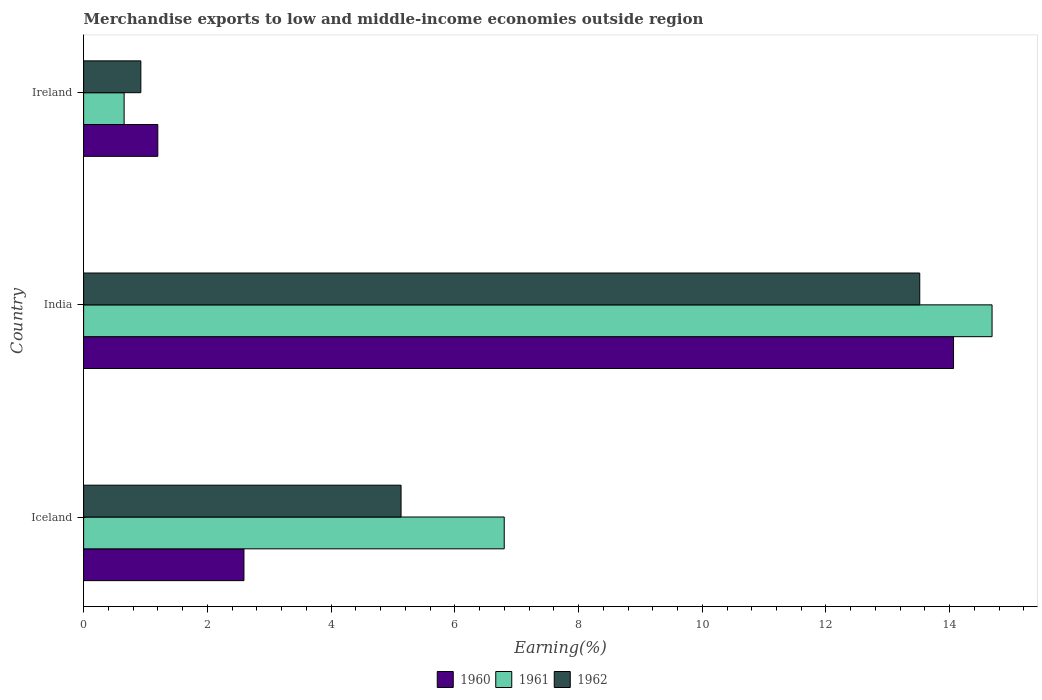How many different coloured bars are there?
Your answer should be very brief. 3. Are the number of bars per tick equal to the number of legend labels?
Your answer should be compact. Yes. Are the number of bars on each tick of the Y-axis equal?
Keep it short and to the point. Yes. How many bars are there on the 1st tick from the top?
Keep it short and to the point. 3. What is the label of the 1st group of bars from the top?
Your answer should be compact. Ireland. In how many cases, is the number of bars for a given country not equal to the number of legend labels?
Give a very brief answer. 0. What is the percentage of amount earned from merchandise exports in 1962 in Iceland?
Your answer should be compact. 5.13. Across all countries, what is the maximum percentage of amount earned from merchandise exports in 1960?
Provide a short and direct response. 14.06. Across all countries, what is the minimum percentage of amount earned from merchandise exports in 1961?
Offer a very short reply. 0.65. In which country was the percentage of amount earned from merchandise exports in 1960 minimum?
Your response must be concise. Ireland. What is the total percentage of amount earned from merchandise exports in 1962 in the graph?
Your answer should be very brief. 19.57. What is the difference between the percentage of amount earned from merchandise exports in 1960 in Iceland and that in India?
Your answer should be very brief. -11.47. What is the difference between the percentage of amount earned from merchandise exports in 1960 in India and the percentage of amount earned from merchandise exports in 1961 in Iceland?
Offer a very short reply. 7.26. What is the average percentage of amount earned from merchandise exports in 1961 per country?
Offer a very short reply. 7.38. What is the difference between the percentage of amount earned from merchandise exports in 1962 and percentage of amount earned from merchandise exports in 1961 in India?
Your answer should be compact. -1.17. In how many countries, is the percentage of amount earned from merchandise exports in 1960 greater than 11.2 %?
Make the answer very short. 1. What is the ratio of the percentage of amount earned from merchandise exports in 1960 in India to that in Ireland?
Make the answer very short. 11.73. Is the percentage of amount earned from merchandise exports in 1960 in Iceland less than that in Ireland?
Offer a terse response. No. Is the difference between the percentage of amount earned from merchandise exports in 1962 in Iceland and Ireland greater than the difference between the percentage of amount earned from merchandise exports in 1961 in Iceland and Ireland?
Your response must be concise. No. What is the difference between the highest and the second highest percentage of amount earned from merchandise exports in 1960?
Ensure brevity in your answer.  11.47. What is the difference between the highest and the lowest percentage of amount earned from merchandise exports in 1960?
Ensure brevity in your answer.  12.86. In how many countries, is the percentage of amount earned from merchandise exports in 1962 greater than the average percentage of amount earned from merchandise exports in 1962 taken over all countries?
Your answer should be very brief. 1. What does the 2nd bar from the top in Iceland represents?
Provide a succinct answer. 1961. Is it the case that in every country, the sum of the percentage of amount earned from merchandise exports in 1960 and percentage of amount earned from merchandise exports in 1961 is greater than the percentage of amount earned from merchandise exports in 1962?
Ensure brevity in your answer.  Yes. What is the difference between two consecutive major ticks on the X-axis?
Keep it short and to the point. 2. Are the values on the major ticks of X-axis written in scientific E-notation?
Give a very brief answer. No. Does the graph contain grids?
Ensure brevity in your answer.  No. How many legend labels are there?
Ensure brevity in your answer.  3. What is the title of the graph?
Your response must be concise. Merchandise exports to low and middle-income economies outside region. Does "2008" appear as one of the legend labels in the graph?
Make the answer very short. No. What is the label or title of the X-axis?
Provide a succinct answer. Earning(%). What is the Earning(%) of 1960 in Iceland?
Make the answer very short. 2.59. What is the Earning(%) of 1961 in Iceland?
Offer a terse response. 6.8. What is the Earning(%) in 1962 in Iceland?
Your answer should be compact. 5.13. What is the Earning(%) in 1960 in India?
Ensure brevity in your answer.  14.06. What is the Earning(%) of 1961 in India?
Offer a terse response. 14.68. What is the Earning(%) in 1962 in India?
Your response must be concise. 13.52. What is the Earning(%) in 1960 in Ireland?
Provide a succinct answer. 1.2. What is the Earning(%) in 1961 in Ireland?
Make the answer very short. 0.65. What is the Earning(%) of 1962 in Ireland?
Your answer should be compact. 0.92. Across all countries, what is the maximum Earning(%) of 1960?
Your response must be concise. 14.06. Across all countries, what is the maximum Earning(%) in 1961?
Give a very brief answer. 14.68. Across all countries, what is the maximum Earning(%) of 1962?
Make the answer very short. 13.52. Across all countries, what is the minimum Earning(%) of 1960?
Your answer should be compact. 1.2. Across all countries, what is the minimum Earning(%) in 1961?
Ensure brevity in your answer.  0.65. Across all countries, what is the minimum Earning(%) of 1962?
Keep it short and to the point. 0.92. What is the total Earning(%) of 1960 in the graph?
Provide a succinct answer. 17.85. What is the total Earning(%) in 1961 in the graph?
Give a very brief answer. 22.14. What is the total Earning(%) in 1962 in the graph?
Your answer should be compact. 19.57. What is the difference between the Earning(%) of 1960 in Iceland and that in India?
Offer a very short reply. -11.47. What is the difference between the Earning(%) of 1961 in Iceland and that in India?
Give a very brief answer. -7.89. What is the difference between the Earning(%) in 1962 in Iceland and that in India?
Offer a very short reply. -8.38. What is the difference between the Earning(%) in 1960 in Iceland and that in Ireland?
Your answer should be compact. 1.39. What is the difference between the Earning(%) in 1961 in Iceland and that in Ireland?
Keep it short and to the point. 6.14. What is the difference between the Earning(%) in 1962 in Iceland and that in Ireland?
Offer a terse response. 4.21. What is the difference between the Earning(%) in 1960 in India and that in Ireland?
Keep it short and to the point. 12.86. What is the difference between the Earning(%) of 1961 in India and that in Ireland?
Provide a short and direct response. 14.03. What is the difference between the Earning(%) of 1962 in India and that in Ireland?
Provide a succinct answer. 12.59. What is the difference between the Earning(%) in 1960 in Iceland and the Earning(%) in 1961 in India?
Your answer should be very brief. -12.09. What is the difference between the Earning(%) in 1960 in Iceland and the Earning(%) in 1962 in India?
Your response must be concise. -10.92. What is the difference between the Earning(%) of 1961 in Iceland and the Earning(%) of 1962 in India?
Provide a short and direct response. -6.72. What is the difference between the Earning(%) of 1960 in Iceland and the Earning(%) of 1961 in Ireland?
Ensure brevity in your answer.  1.94. What is the difference between the Earning(%) in 1960 in Iceland and the Earning(%) in 1962 in Ireland?
Your response must be concise. 1.67. What is the difference between the Earning(%) in 1961 in Iceland and the Earning(%) in 1962 in Ireland?
Provide a succinct answer. 5.87. What is the difference between the Earning(%) in 1960 in India and the Earning(%) in 1961 in Ireland?
Offer a terse response. 13.41. What is the difference between the Earning(%) of 1960 in India and the Earning(%) of 1962 in Ireland?
Make the answer very short. 13.14. What is the difference between the Earning(%) in 1961 in India and the Earning(%) in 1962 in Ireland?
Keep it short and to the point. 13.76. What is the average Earning(%) in 1960 per country?
Provide a succinct answer. 5.95. What is the average Earning(%) in 1961 per country?
Provide a succinct answer. 7.38. What is the average Earning(%) of 1962 per country?
Provide a succinct answer. 6.52. What is the difference between the Earning(%) of 1960 and Earning(%) of 1961 in Iceland?
Offer a very short reply. -4.21. What is the difference between the Earning(%) of 1960 and Earning(%) of 1962 in Iceland?
Keep it short and to the point. -2.54. What is the difference between the Earning(%) in 1961 and Earning(%) in 1962 in Iceland?
Keep it short and to the point. 1.67. What is the difference between the Earning(%) of 1960 and Earning(%) of 1961 in India?
Your answer should be very brief. -0.62. What is the difference between the Earning(%) of 1960 and Earning(%) of 1962 in India?
Keep it short and to the point. 0.55. What is the difference between the Earning(%) in 1961 and Earning(%) in 1962 in India?
Give a very brief answer. 1.17. What is the difference between the Earning(%) in 1960 and Earning(%) in 1961 in Ireland?
Offer a terse response. 0.54. What is the difference between the Earning(%) in 1960 and Earning(%) in 1962 in Ireland?
Keep it short and to the point. 0.27. What is the difference between the Earning(%) of 1961 and Earning(%) of 1962 in Ireland?
Provide a succinct answer. -0.27. What is the ratio of the Earning(%) in 1960 in Iceland to that in India?
Provide a succinct answer. 0.18. What is the ratio of the Earning(%) of 1961 in Iceland to that in India?
Your answer should be very brief. 0.46. What is the ratio of the Earning(%) in 1962 in Iceland to that in India?
Your response must be concise. 0.38. What is the ratio of the Earning(%) of 1960 in Iceland to that in Ireland?
Offer a very short reply. 2.16. What is the ratio of the Earning(%) of 1961 in Iceland to that in Ireland?
Give a very brief answer. 10.39. What is the ratio of the Earning(%) of 1962 in Iceland to that in Ireland?
Offer a very short reply. 5.55. What is the ratio of the Earning(%) of 1960 in India to that in Ireland?
Provide a succinct answer. 11.73. What is the ratio of the Earning(%) in 1961 in India to that in Ireland?
Offer a terse response. 22.44. What is the ratio of the Earning(%) of 1962 in India to that in Ireland?
Make the answer very short. 14.61. What is the difference between the highest and the second highest Earning(%) in 1960?
Provide a short and direct response. 11.47. What is the difference between the highest and the second highest Earning(%) of 1961?
Your answer should be very brief. 7.89. What is the difference between the highest and the second highest Earning(%) of 1962?
Offer a very short reply. 8.38. What is the difference between the highest and the lowest Earning(%) in 1960?
Ensure brevity in your answer.  12.86. What is the difference between the highest and the lowest Earning(%) in 1961?
Provide a succinct answer. 14.03. What is the difference between the highest and the lowest Earning(%) of 1962?
Your answer should be very brief. 12.59. 